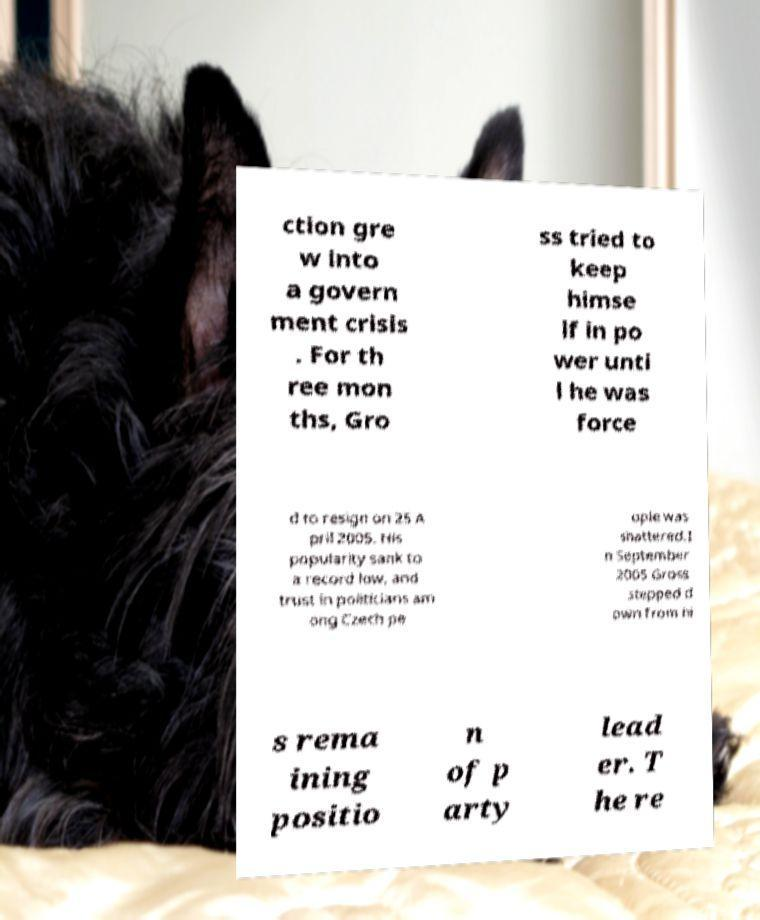Please read and relay the text visible in this image. What does it say? ction gre w into a govern ment crisis . For th ree mon ths, Gro ss tried to keep himse lf in po wer unti l he was force d to resign on 25 A pril 2005. His popularity sank to a record low, and trust in politicians am ong Czech pe ople was shattered.I n September 2005 Gross stepped d own from hi s rema ining positio n of p arty lead er. T he re 